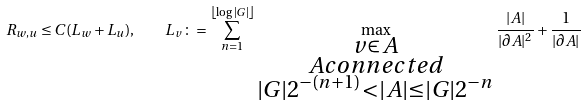<formula> <loc_0><loc_0><loc_500><loc_500>R _ { w , u } \leq C ( L _ { w } + L _ { u } ) , \quad L _ { v } \colon = \sum _ { n = 1 } ^ { \left \lfloor \log | G | \right \rfloor } \max _ { \substack { v \in A \\ A c o n n e c t e d \\ | G | 2 ^ { - ( n + 1 ) } < | A | \leq | G | 2 ^ { - n } } } \frac { | A | } { | \partial A | ^ { 2 } } + \frac { 1 } { | \partial A | }</formula> 